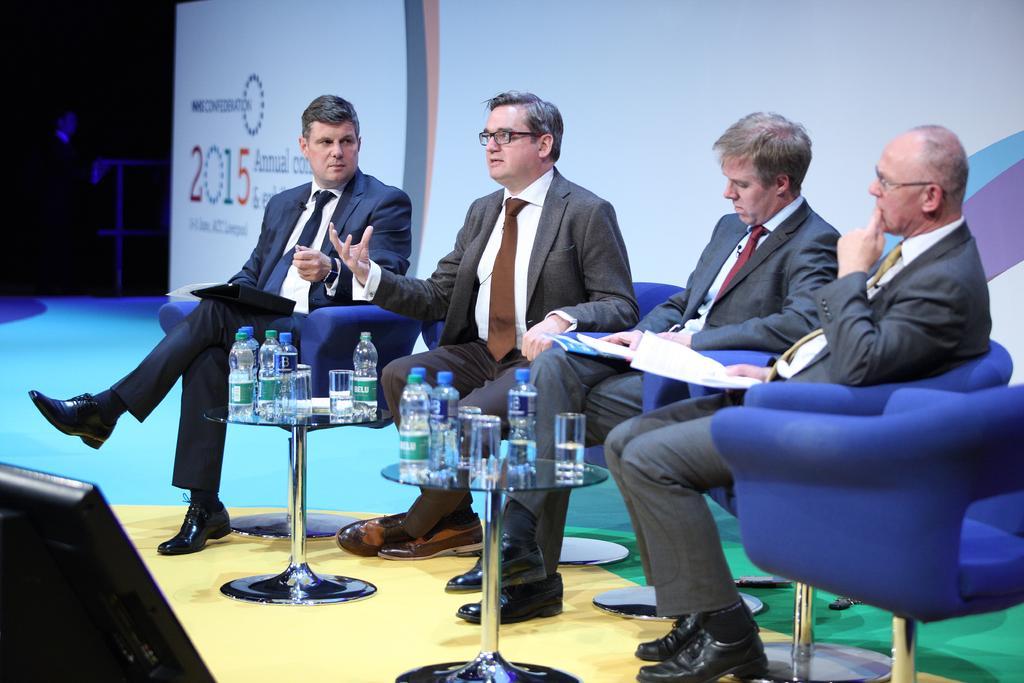In one or two sentences, can you explain what this image depicts? There are four persons sitting on chair by wearing suit and tie. At the right corner, person is holding papers in his hand. Person in the middle of picture is making a hand gesture. There are two tables in front of them having glasses and few bottles on top of it. Left corner of image there is monitor. 